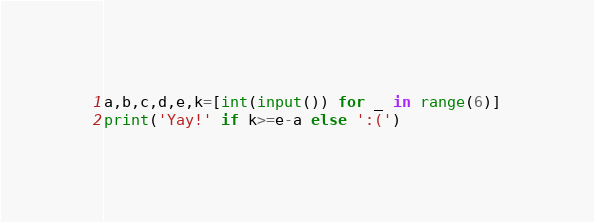Convert code to text. <code><loc_0><loc_0><loc_500><loc_500><_Python_>a,b,c,d,e,k=[int(input()) for _ in range(6)]
print('Yay!' if k>=e-a else ':(')</code> 